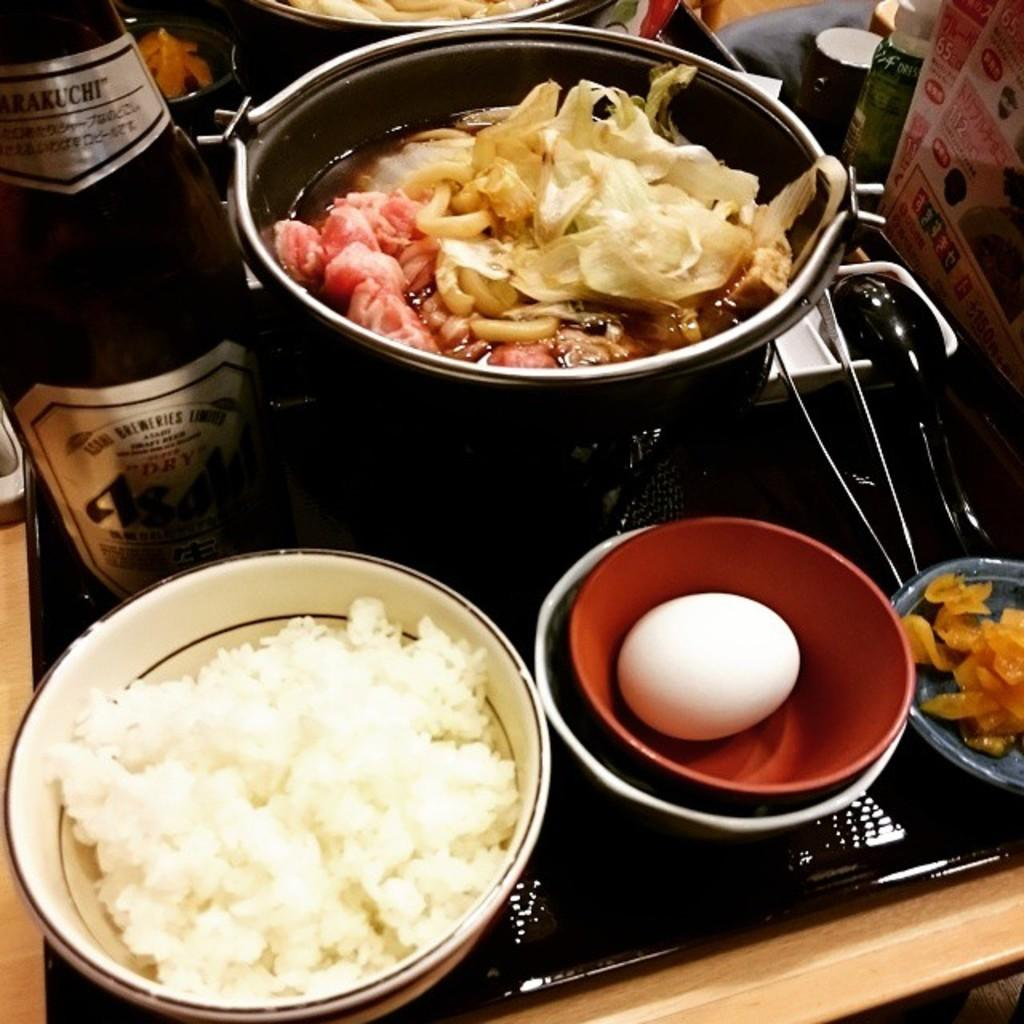<image>
Describe the image concisely. Bottle of Asalif beer next to some bowls of food. 